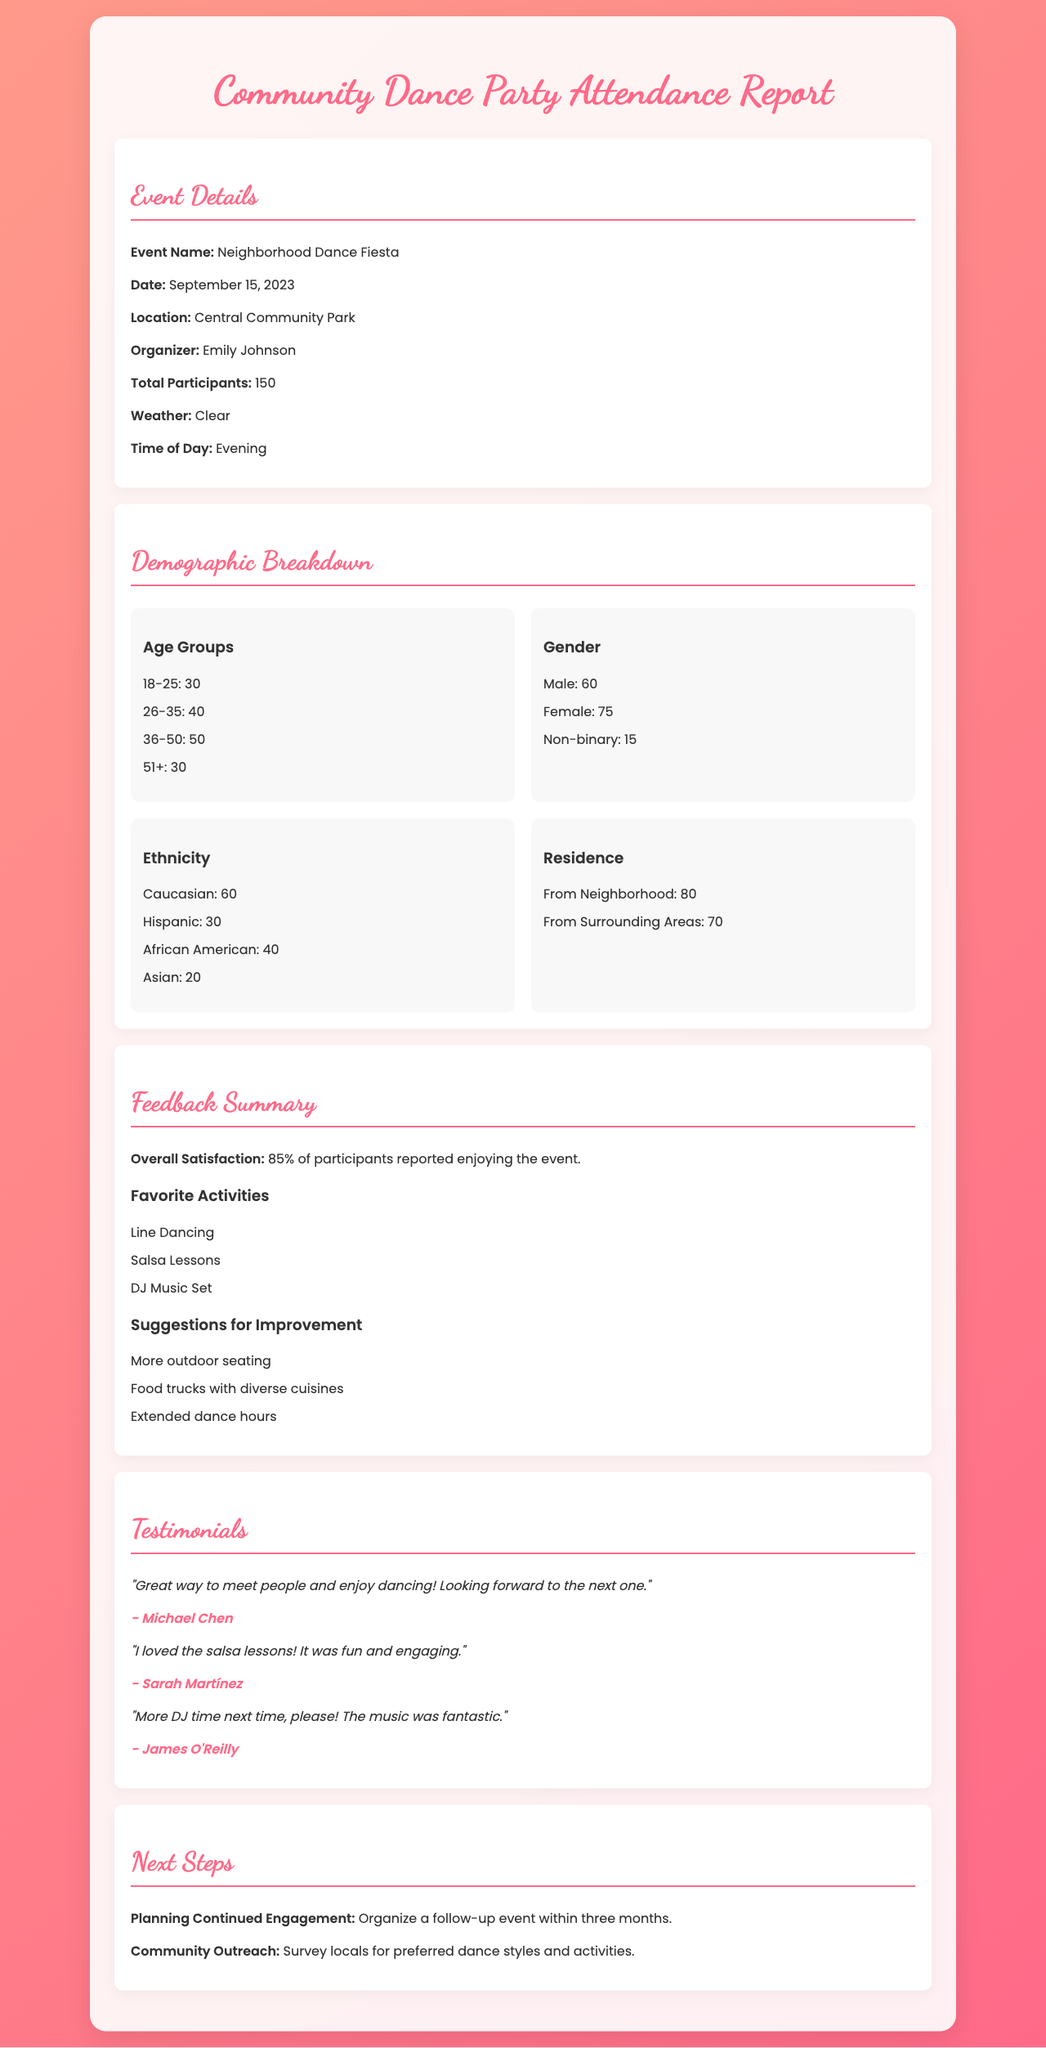what was the event name? The event name is listed in the event details section of the report as "Neighborhood Dance Fiesta."
Answer: Neighborhood Dance Fiesta what was the date of the event? The date is provided in the event details section as September 15, 2023.
Answer: September 15, 2023 how many participants attended the event? The total number of participants is stated in the event details section as 150.
Answer: 150 what percentage of participants reported enjoying the event? The overall satisfaction percentage is mentioned in the feedback summary as 85%.
Answer: 85% which age group had the highest attendance? The demographics section shows that the age group 36-50 had the highest attendance, totaling 50 participants.
Answer: 36-50 what was the most suggested improvement? The feedback section lists several suggestions, with "More outdoor seating" being one of them.
Answer: More outdoor seating how many males attended the event? The gender breakdown in the demographics section specifies that 60 males attended.
Answer: 60 who organized the event? The organizer's name is mentioned in the event details as Emily Johnson.
Answer: Emily Johnson what activity was favored the most? The favorite activities section lists "Line Dancing" as one of the preferred activities.
Answer: Line Dancing 